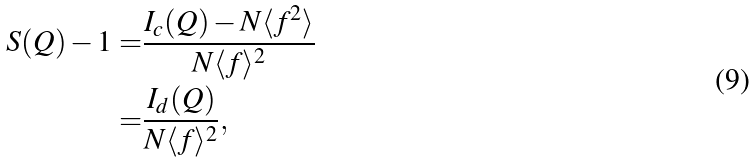<formula> <loc_0><loc_0><loc_500><loc_500>S ( Q ) - 1 = & \frac { I _ { c } ( Q ) - N \langle f ^ { 2 } \rangle } { N \langle f \rangle ^ { 2 } } \\ = & \frac { I _ { d } ( Q ) } { N \langle f \rangle ^ { 2 } } ,</formula> 